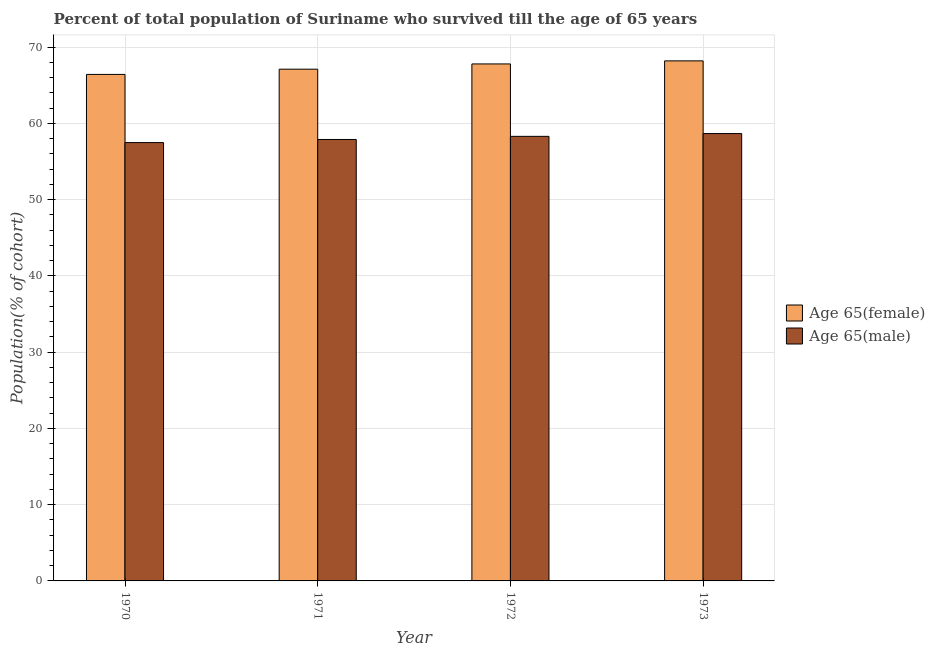How many groups of bars are there?
Your response must be concise. 4. How many bars are there on the 2nd tick from the right?
Your response must be concise. 2. What is the label of the 2nd group of bars from the left?
Offer a terse response. 1971. What is the percentage of female population who survived till age of 65 in 1971?
Your answer should be very brief. 67.12. Across all years, what is the maximum percentage of female population who survived till age of 65?
Your response must be concise. 68.21. Across all years, what is the minimum percentage of female population who survived till age of 65?
Provide a short and direct response. 66.43. What is the total percentage of male population who survived till age of 65 in the graph?
Your answer should be compact. 232.38. What is the difference between the percentage of female population who survived till age of 65 in 1971 and that in 1973?
Keep it short and to the point. -1.09. What is the difference between the percentage of male population who survived till age of 65 in 1971 and the percentage of female population who survived till age of 65 in 1970?
Your answer should be very brief. 0.41. What is the average percentage of female population who survived till age of 65 per year?
Offer a terse response. 67.39. What is the ratio of the percentage of female population who survived till age of 65 in 1970 to that in 1973?
Offer a very short reply. 0.97. What is the difference between the highest and the second highest percentage of male population who survived till age of 65?
Provide a succinct answer. 0.37. What is the difference between the highest and the lowest percentage of male population who survived till age of 65?
Offer a very short reply. 1.19. What does the 2nd bar from the left in 1973 represents?
Your response must be concise. Age 65(male). What does the 2nd bar from the right in 1971 represents?
Your response must be concise. Age 65(female). How many bars are there?
Your answer should be compact. 8. Are all the bars in the graph horizontal?
Ensure brevity in your answer.  No. What is the difference between two consecutive major ticks on the Y-axis?
Give a very brief answer. 10. Are the values on the major ticks of Y-axis written in scientific E-notation?
Provide a succinct answer. No. Does the graph contain grids?
Provide a succinct answer. Yes. Where does the legend appear in the graph?
Your response must be concise. Center right. How many legend labels are there?
Keep it short and to the point. 2. What is the title of the graph?
Ensure brevity in your answer.  Percent of total population of Suriname who survived till the age of 65 years. What is the label or title of the Y-axis?
Offer a very short reply. Population(% of cohort). What is the Population(% of cohort) of Age 65(female) in 1970?
Your answer should be compact. 66.43. What is the Population(% of cohort) in Age 65(male) in 1970?
Offer a very short reply. 57.49. What is the Population(% of cohort) of Age 65(female) in 1971?
Ensure brevity in your answer.  67.12. What is the Population(% of cohort) in Age 65(male) in 1971?
Provide a succinct answer. 57.9. What is the Population(% of cohort) in Age 65(female) in 1972?
Provide a succinct answer. 67.81. What is the Population(% of cohort) of Age 65(male) in 1972?
Make the answer very short. 58.31. What is the Population(% of cohort) of Age 65(female) in 1973?
Keep it short and to the point. 68.21. What is the Population(% of cohort) of Age 65(male) in 1973?
Offer a very short reply. 58.68. Across all years, what is the maximum Population(% of cohort) in Age 65(female)?
Offer a terse response. 68.21. Across all years, what is the maximum Population(% of cohort) of Age 65(male)?
Your answer should be compact. 58.68. Across all years, what is the minimum Population(% of cohort) in Age 65(female)?
Make the answer very short. 66.43. Across all years, what is the minimum Population(% of cohort) in Age 65(male)?
Your response must be concise. 57.49. What is the total Population(% of cohort) of Age 65(female) in the graph?
Your answer should be compact. 269.57. What is the total Population(% of cohort) in Age 65(male) in the graph?
Keep it short and to the point. 232.38. What is the difference between the Population(% of cohort) in Age 65(female) in 1970 and that in 1971?
Offer a very short reply. -0.69. What is the difference between the Population(% of cohort) of Age 65(male) in 1970 and that in 1971?
Your answer should be very brief. -0.41. What is the difference between the Population(% of cohort) of Age 65(female) in 1970 and that in 1972?
Give a very brief answer. -1.38. What is the difference between the Population(% of cohort) of Age 65(male) in 1970 and that in 1972?
Provide a succinct answer. -0.82. What is the difference between the Population(% of cohort) of Age 65(female) in 1970 and that in 1973?
Make the answer very short. -1.78. What is the difference between the Population(% of cohort) of Age 65(male) in 1970 and that in 1973?
Offer a terse response. -1.19. What is the difference between the Population(% of cohort) of Age 65(female) in 1971 and that in 1972?
Provide a short and direct response. -0.69. What is the difference between the Population(% of cohort) of Age 65(male) in 1971 and that in 1972?
Offer a very short reply. -0.41. What is the difference between the Population(% of cohort) in Age 65(female) in 1971 and that in 1973?
Offer a terse response. -1.09. What is the difference between the Population(% of cohort) in Age 65(male) in 1971 and that in 1973?
Offer a terse response. -0.78. What is the difference between the Population(% of cohort) in Age 65(female) in 1972 and that in 1973?
Offer a very short reply. -0.4. What is the difference between the Population(% of cohort) in Age 65(male) in 1972 and that in 1973?
Provide a succinct answer. -0.37. What is the difference between the Population(% of cohort) in Age 65(female) in 1970 and the Population(% of cohort) in Age 65(male) in 1971?
Your answer should be very brief. 8.53. What is the difference between the Population(% of cohort) of Age 65(female) in 1970 and the Population(% of cohort) of Age 65(male) in 1972?
Give a very brief answer. 8.12. What is the difference between the Population(% of cohort) in Age 65(female) in 1970 and the Population(% of cohort) in Age 65(male) in 1973?
Offer a very short reply. 7.76. What is the difference between the Population(% of cohort) of Age 65(female) in 1971 and the Population(% of cohort) of Age 65(male) in 1972?
Provide a succinct answer. 8.81. What is the difference between the Population(% of cohort) of Age 65(female) in 1971 and the Population(% of cohort) of Age 65(male) in 1973?
Give a very brief answer. 8.44. What is the difference between the Population(% of cohort) in Age 65(female) in 1972 and the Population(% of cohort) in Age 65(male) in 1973?
Make the answer very short. 9.13. What is the average Population(% of cohort) in Age 65(female) per year?
Provide a succinct answer. 67.39. What is the average Population(% of cohort) of Age 65(male) per year?
Make the answer very short. 58.09. In the year 1970, what is the difference between the Population(% of cohort) in Age 65(female) and Population(% of cohort) in Age 65(male)?
Offer a very short reply. 8.94. In the year 1971, what is the difference between the Population(% of cohort) of Age 65(female) and Population(% of cohort) of Age 65(male)?
Your response must be concise. 9.22. In the year 1972, what is the difference between the Population(% of cohort) of Age 65(female) and Population(% of cohort) of Age 65(male)?
Provide a short and direct response. 9.5. In the year 1973, what is the difference between the Population(% of cohort) in Age 65(female) and Population(% of cohort) in Age 65(male)?
Your answer should be very brief. 9.53. What is the ratio of the Population(% of cohort) in Age 65(female) in 1970 to that in 1971?
Your response must be concise. 0.99. What is the ratio of the Population(% of cohort) of Age 65(female) in 1970 to that in 1972?
Your response must be concise. 0.98. What is the ratio of the Population(% of cohort) of Age 65(female) in 1970 to that in 1973?
Make the answer very short. 0.97. What is the ratio of the Population(% of cohort) in Age 65(male) in 1970 to that in 1973?
Offer a terse response. 0.98. What is the ratio of the Population(% of cohort) in Age 65(female) in 1971 to that in 1973?
Provide a short and direct response. 0.98. What is the ratio of the Population(% of cohort) in Age 65(male) in 1971 to that in 1973?
Provide a succinct answer. 0.99. What is the ratio of the Population(% of cohort) of Age 65(male) in 1972 to that in 1973?
Your answer should be very brief. 0.99. What is the difference between the highest and the second highest Population(% of cohort) of Age 65(female)?
Provide a succinct answer. 0.4. What is the difference between the highest and the second highest Population(% of cohort) of Age 65(male)?
Ensure brevity in your answer.  0.37. What is the difference between the highest and the lowest Population(% of cohort) in Age 65(female)?
Your answer should be compact. 1.78. What is the difference between the highest and the lowest Population(% of cohort) of Age 65(male)?
Make the answer very short. 1.19. 